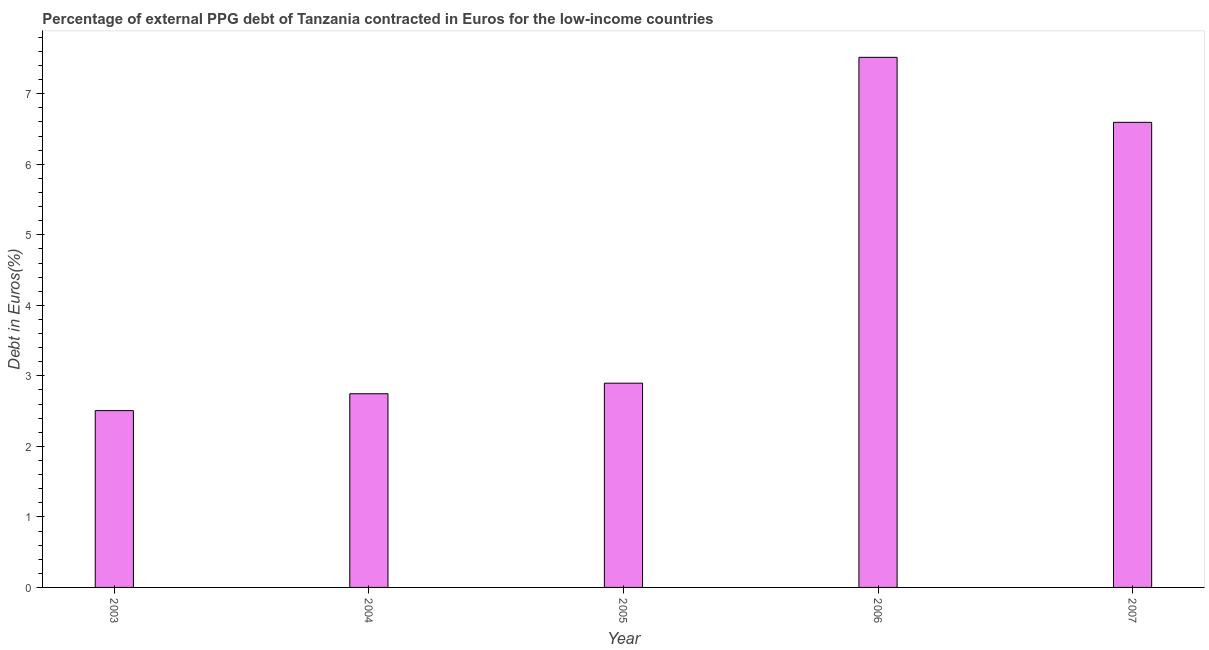What is the title of the graph?
Make the answer very short. Percentage of external PPG debt of Tanzania contracted in Euros for the low-income countries. What is the label or title of the Y-axis?
Keep it short and to the point. Debt in Euros(%). What is the currency composition of ppg debt in 2004?
Offer a very short reply. 2.75. Across all years, what is the maximum currency composition of ppg debt?
Keep it short and to the point. 7.52. Across all years, what is the minimum currency composition of ppg debt?
Your response must be concise. 2.51. What is the sum of the currency composition of ppg debt?
Keep it short and to the point. 22.26. What is the difference between the currency composition of ppg debt in 2004 and 2007?
Give a very brief answer. -3.85. What is the average currency composition of ppg debt per year?
Offer a terse response. 4.45. What is the median currency composition of ppg debt?
Ensure brevity in your answer.  2.9. In how many years, is the currency composition of ppg debt greater than 6.2 %?
Keep it short and to the point. 2. What is the ratio of the currency composition of ppg debt in 2005 to that in 2007?
Your response must be concise. 0.44. Is the currency composition of ppg debt in 2005 less than that in 2007?
Offer a very short reply. Yes. What is the difference between the highest and the second highest currency composition of ppg debt?
Give a very brief answer. 0.92. Is the sum of the currency composition of ppg debt in 2004 and 2007 greater than the maximum currency composition of ppg debt across all years?
Your answer should be very brief. Yes. What is the difference between the highest and the lowest currency composition of ppg debt?
Provide a short and direct response. 5.01. How many bars are there?
Offer a very short reply. 5. How many years are there in the graph?
Your answer should be very brief. 5. What is the difference between two consecutive major ticks on the Y-axis?
Give a very brief answer. 1. Are the values on the major ticks of Y-axis written in scientific E-notation?
Your answer should be compact. No. What is the Debt in Euros(%) in 2003?
Make the answer very short. 2.51. What is the Debt in Euros(%) of 2004?
Offer a very short reply. 2.75. What is the Debt in Euros(%) of 2005?
Keep it short and to the point. 2.9. What is the Debt in Euros(%) in 2006?
Offer a terse response. 7.52. What is the Debt in Euros(%) in 2007?
Offer a very short reply. 6.59. What is the difference between the Debt in Euros(%) in 2003 and 2004?
Ensure brevity in your answer.  -0.24. What is the difference between the Debt in Euros(%) in 2003 and 2005?
Offer a terse response. -0.39. What is the difference between the Debt in Euros(%) in 2003 and 2006?
Keep it short and to the point. -5.01. What is the difference between the Debt in Euros(%) in 2003 and 2007?
Provide a short and direct response. -4.09. What is the difference between the Debt in Euros(%) in 2004 and 2005?
Offer a very short reply. -0.15. What is the difference between the Debt in Euros(%) in 2004 and 2006?
Offer a very short reply. -4.77. What is the difference between the Debt in Euros(%) in 2004 and 2007?
Your answer should be very brief. -3.85. What is the difference between the Debt in Euros(%) in 2005 and 2006?
Make the answer very short. -4.62. What is the difference between the Debt in Euros(%) in 2005 and 2007?
Provide a succinct answer. -3.7. What is the difference between the Debt in Euros(%) in 2006 and 2007?
Your response must be concise. 0.92. What is the ratio of the Debt in Euros(%) in 2003 to that in 2004?
Your answer should be very brief. 0.91. What is the ratio of the Debt in Euros(%) in 2003 to that in 2005?
Provide a short and direct response. 0.87. What is the ratio of the Debt in Euros(%) in 2003 to that in 2006?
Your answer should be compact. 0.33. What is the ratio of the Debt in Euros(%) in 2003 to that in 2007?
Provide a short and direct response. 0.38. What is the ratio of the Debt in Euros(%) in 2004 to that in 2005?
Offer a very short reply. 0.95. What is the ratio of the Debt in Euros(%) in 2004 to that in 2006?
Your answer should be compact. 0.36. What is the ratio of the Debt in Euros(%) in 2004 to that in 2007?
Offer a terse response. 0.42. What is the ratio of the Debt in Euros(%) in 2005 to that in 2006?
Keep it short and to the point. 0.39. What is the ratio of the Debt in Euros(%) in 2005 to that in 2007?
Ensure brevity in your answer.  0.44. What is the ratio of the Debt in Euros(%) in 2006 to that in 2007?
Your answer should be very brief. 1.14. 